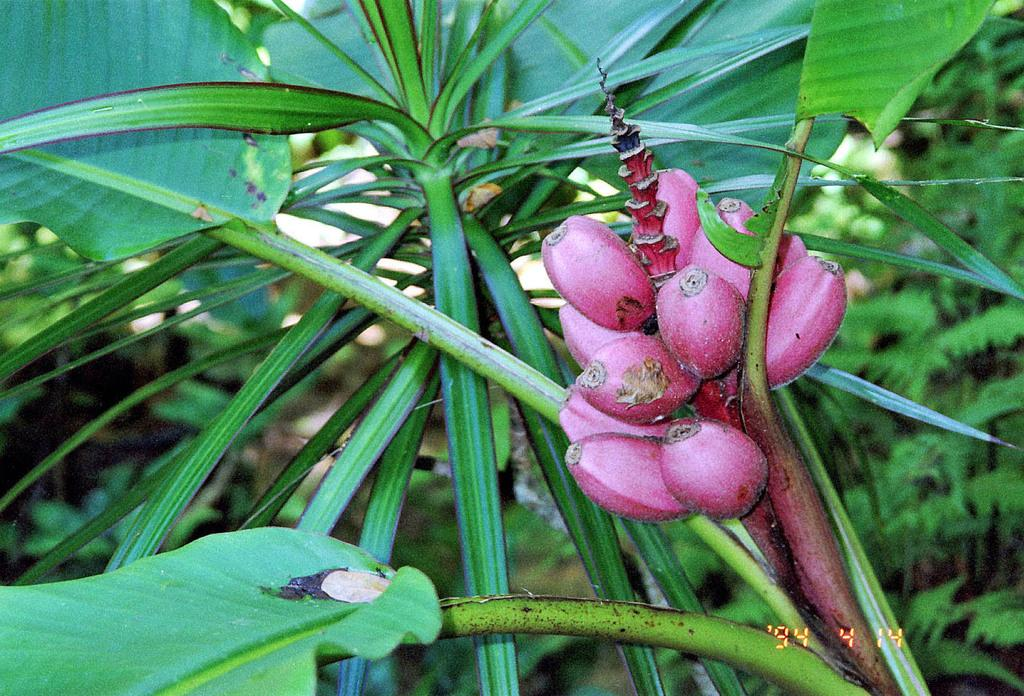What is located on the stem of a plant in the image? There is a group of fruits on the stem of a plant in the image. What can be seen in the background of the image? There is a group of plants visible in the background of the image. How do the fruits show respect to the plants in the image? The fruits do not show respect to the plants in the image, as they are simply fruits on the stem of a plant. 